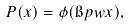<formula> <loc_0><loc_0><loc_500><loc_500>P ( x ) = \phi ( \i p { w } { x } ) ,</formula> 